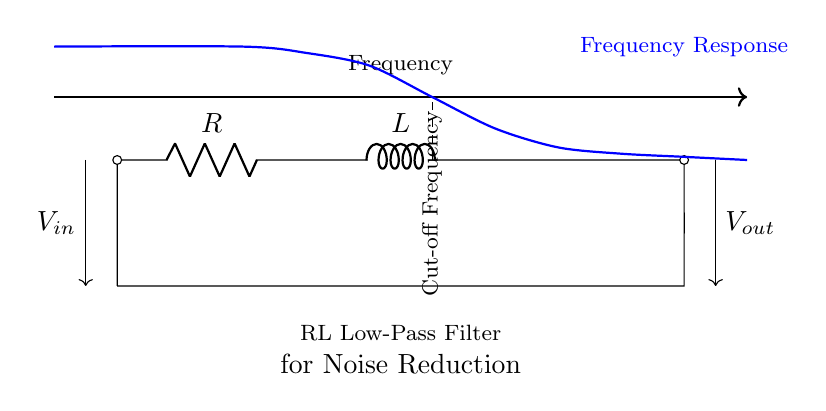What are the components in this circuit? The circuit contains a resistor and an inductor, which are the fundamental components shown as "R" and "L" in the diagram. The "R" is labeled as a resistor, and "L" is labeled as an inductor, indicating the specific components used in this filter circuit.
Answer: Resistor, Inductor What type of filter is represented in this circuit? The diagram indicates a low-pass filter configuration, as evidenced by the arrangement of the resistor and inductor, which allows low-frequency signals to pass through while attenuating higher frequencies. This is typically characteristic of RL filters.
Answer: Low-pass filter What is the function of this RL filter? The purpose of this RL filter is to reduce noise by allowing only certain frequencies to pass through while filtering out undesired noise, thus improving the signal quality. This function is indicated clearly in the description beneath the circuit legend.
Answer: Noise reduction What is the cut-off frequency of this circuit? The cut-off frequency is the point in the frequency response graph where the output voltage starts to decrease significantly. In the diagram, a vertical dashed line indicates this point, showing it as a reference for frequency response. Based on the provided information, the exact numerical value is not given, but it's typically calculated based on the resistance and inductance values in a practical scenario.
Answer: Not provided How does the inductor affect the frequency response? The inductor contributes to the filtering characteristics by providing reactance that increases with frequency. As frequency increases, the inductor begins to oppose current flow, causing attenuation of the higher frequencies in the output signal. Thus, the inductor plays a crucial role in defining the cut-off frequency and shaping the response curve.
Answer: Attenuates high frequencies 